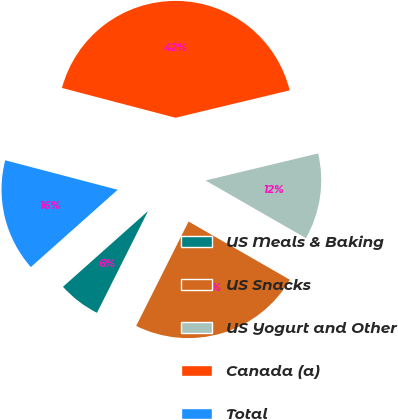<chart> <loc_0><loc_0><loc_500><loc_500><pie_chart><fcel>US Meals & Baking<fcel>US Snacks<fcel>US Yogurt and Other<fcel>Canada (a)<fcel>Total<nl><fcel>6.02%<fcel>24.1%<fcel>12.05%<fcel>42.17%<fcel>15.66%<nl></chart> 